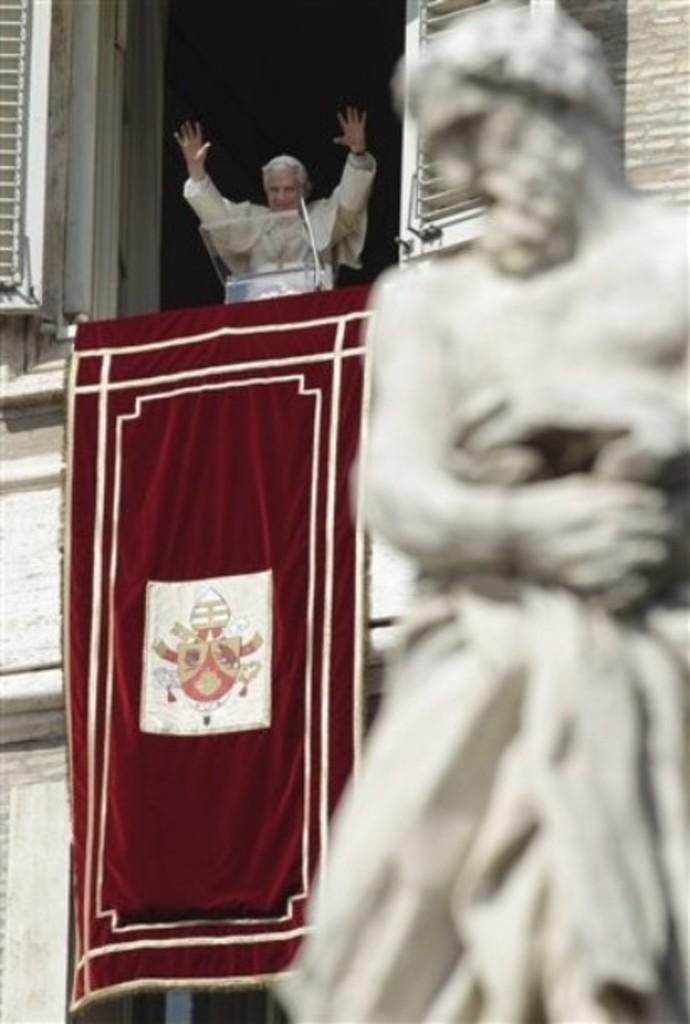What is the main subject in the image? There is a statue in the image. Can you describe the appearance of the statue? The statue is white in color. What else can be seen in the image besides the statue? There is a building in the image, and a red-colored cloth is attached to the building. Is there anyone present in the image? Yes, there is a person standing inside the building. How far away is the plane from the statue in the image? There is no plane present in the image, so it is not possible to determine the distance between a plane and the statue. 